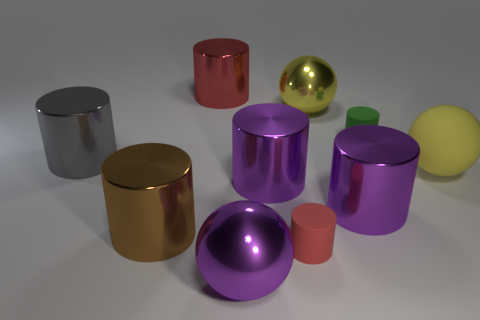Subtract 1 cylinders. How many cylinders are left? 6 Subtract all green cylinders. How many cylinders are left? 6 Subtract all big red metal cylinders. How many cylinders are left? 6 Subtract all yellow cylinders. Subtract all green balls. How many cylinders are left? 7 Subtract all spheres. How many objects are left? 7 Add 8 yellow rubber spheres. How many yellow rubber spheres exist? 9 Subtract 0 cyan cubes. How many objects are left? 10 Subtract all blue metal blocks. Subtract all gray metal cylinders. How many objects are left? 9 Add 8 large gray objects. How many large gray objects are left? 9 